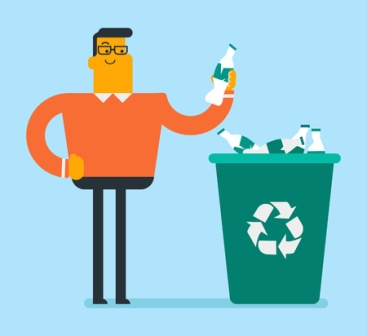If this image were part of a campaign, what kind of campaign would it be? If included in a campaign, this image would likely be part of an environmental awareness initiative. It could fit into campaigns promoting recycling, sustainability, and reducing waste. The campaign would aim to educate people on the importance of recycling and encourage them to adopt more environmentally friendly habits. 